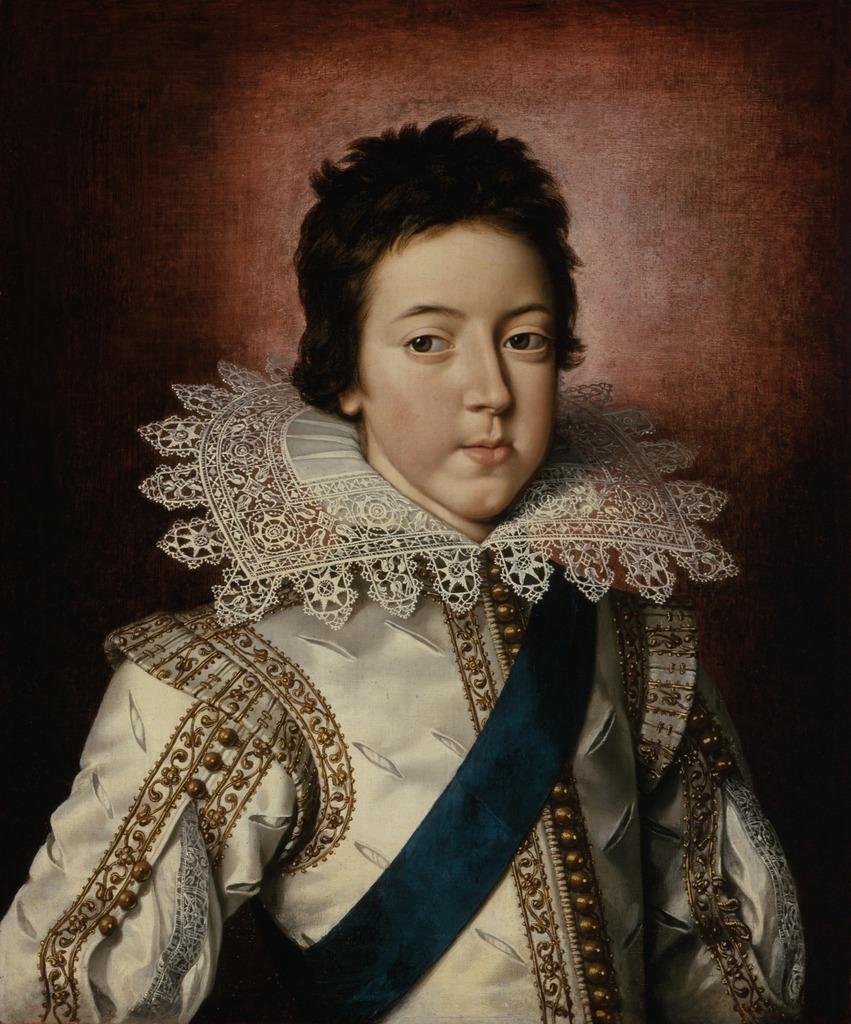What type of artwork is the image? The image is a painting. What is the main subject of the painting? The painting depicts a person. How many leaves are present on the person in the painting? There are no leaves present on the person in the painting, as it is a depiction of a person and not a plant or tree. 